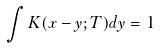<formula> <loc_0><loc_0><loc_500><loc_500>\int K ( x - y ; T ) d y = 1</formula> 